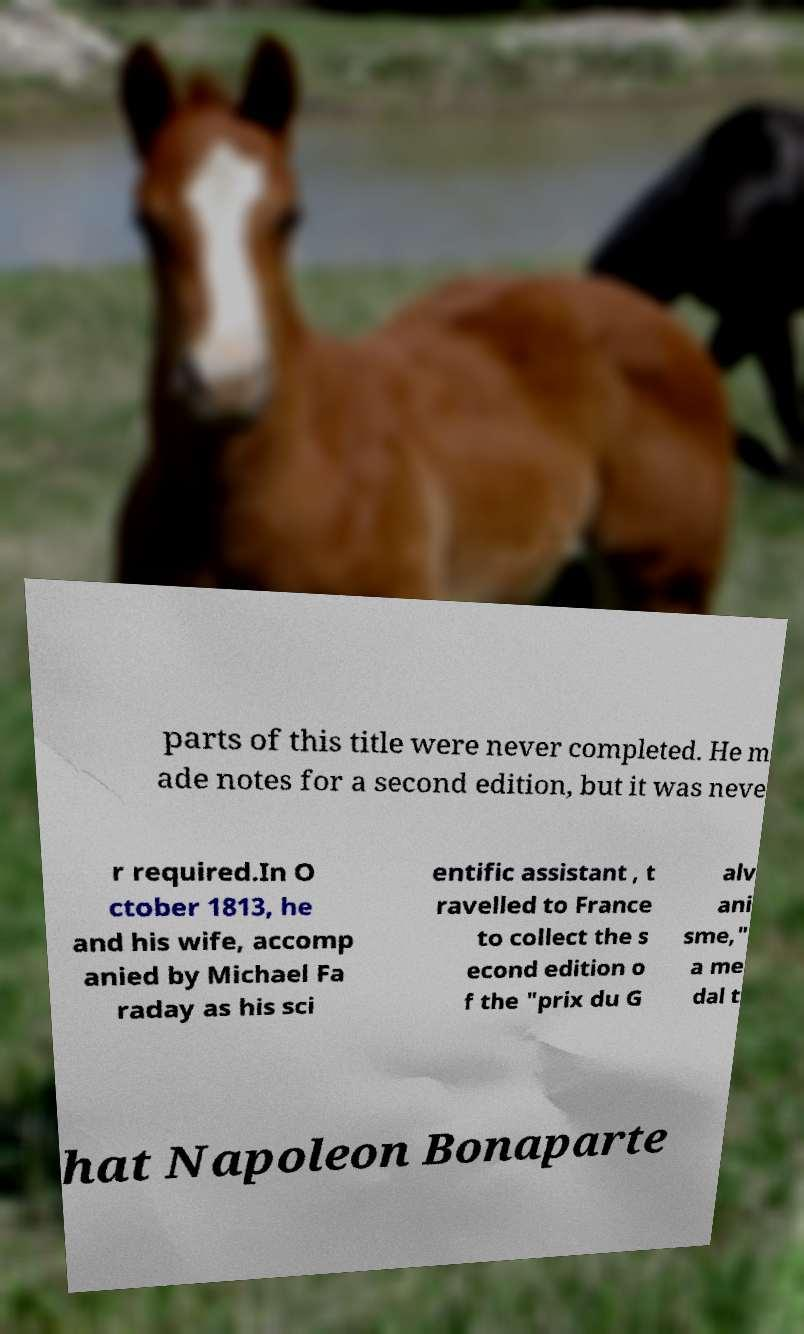For documentation purposes, I need the text within this image transcribed. Could you provide that? parts of this title were never completed. He m ade notes for a second edition, but it was neve r required.In O ctober 1813, he and his wife, accomp anied by Michael Fa raday as his sci entific assistant , t ravelled to France to collect the s econd edition o f the "prix du G alv ani sme," a me dal t hat Napoleon Bonaparte 